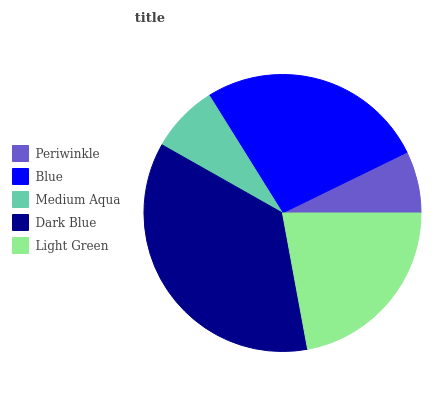Is Periwinkle the minimum?
Answer yes or no. Yes. Is Dark Blue the maximum?
Answer yes or no. Yes. Is Blue the minimum?
Answer yes or no. No. Is Blue the maximum?
Answer yes or no. No. Is Blue greater than Periwinkle?
Answer yes or no. Yes. Is Periwinkle less than Blue?
Answer yes or no. Yes. Is Periwinkle greater than Blue?
Answer yes or no. No. Is Blue less than Periwinkle?
Answer yes or no. No. Is Light Green the high median?
Answer yes or no. Yes. Is Light Green the low median?
Answer yes or no. Yes. Is Periwinkle the high median?
Answer yes or no. No. Is Blue the low median?
Answer yes or no. No. 